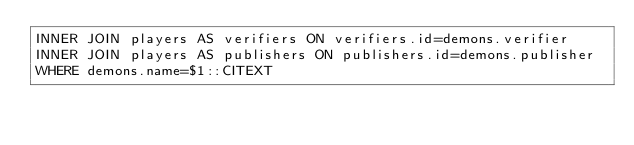Convert code to text. <code><loc_0><loc_0><loc_500><loc_500><_SQL_>INNER JOIN players AS verifiers ON verifiers.id=demons.verifier
INNER JOIN players AS publishers ON publishers.id=demons.publisher
WHERE demons.name=$1::CITEXT</code> 